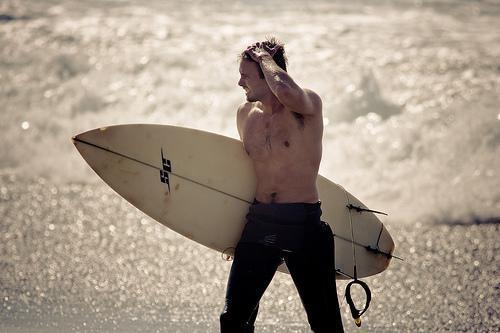How many people are there?
Give a very brief answer. 1. 